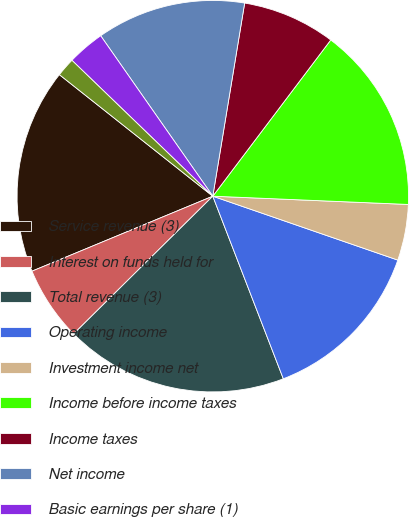Convert chart to OTSL. <chart><loc_0><loc_0><loc_500><loc_500><pie_chart><fcel>Service revenue (3)<fcel>Interest on funds held for<fcel>Total revenue (3)<fcel>Operating income<fcel>Investment income net<fcel>Income before income taxes<fcel>Income taxes<fcel>Net income<fcel>Basic earnings per share (1)<fcel>Diluted earnings per share (1)<nl><fcel>16.92%<fcel>6.16%<fcel>18.45%<fcel>13.84%<fcel>4.62%<fcel>15.38%<fcel>7.69%<fcel>12.31%<fcel>3.08%<fcel>1.55%<nl></chart> 